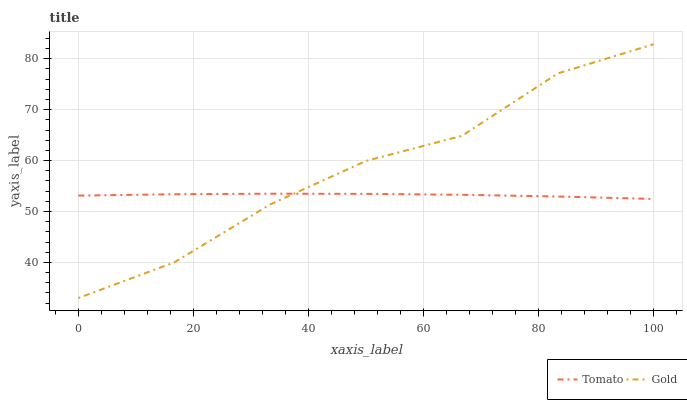Does Tomato have the minimum area under the curve?
Answer yes or no. Yes. Does Gold have the maximum area under the curve?
Answer yes or no. Yes. Does Gold have the minimum area under the curve?
Answer yes or no. No. Is Tomato the smoothest?
Answer yes or no. Yes. Is Gold the roughest?
Answer yes or no. Yes. Is Gold the smoothest?
Answer yes or no. No. Does Gold have the highest value?
Answer yes or no. Yes. 